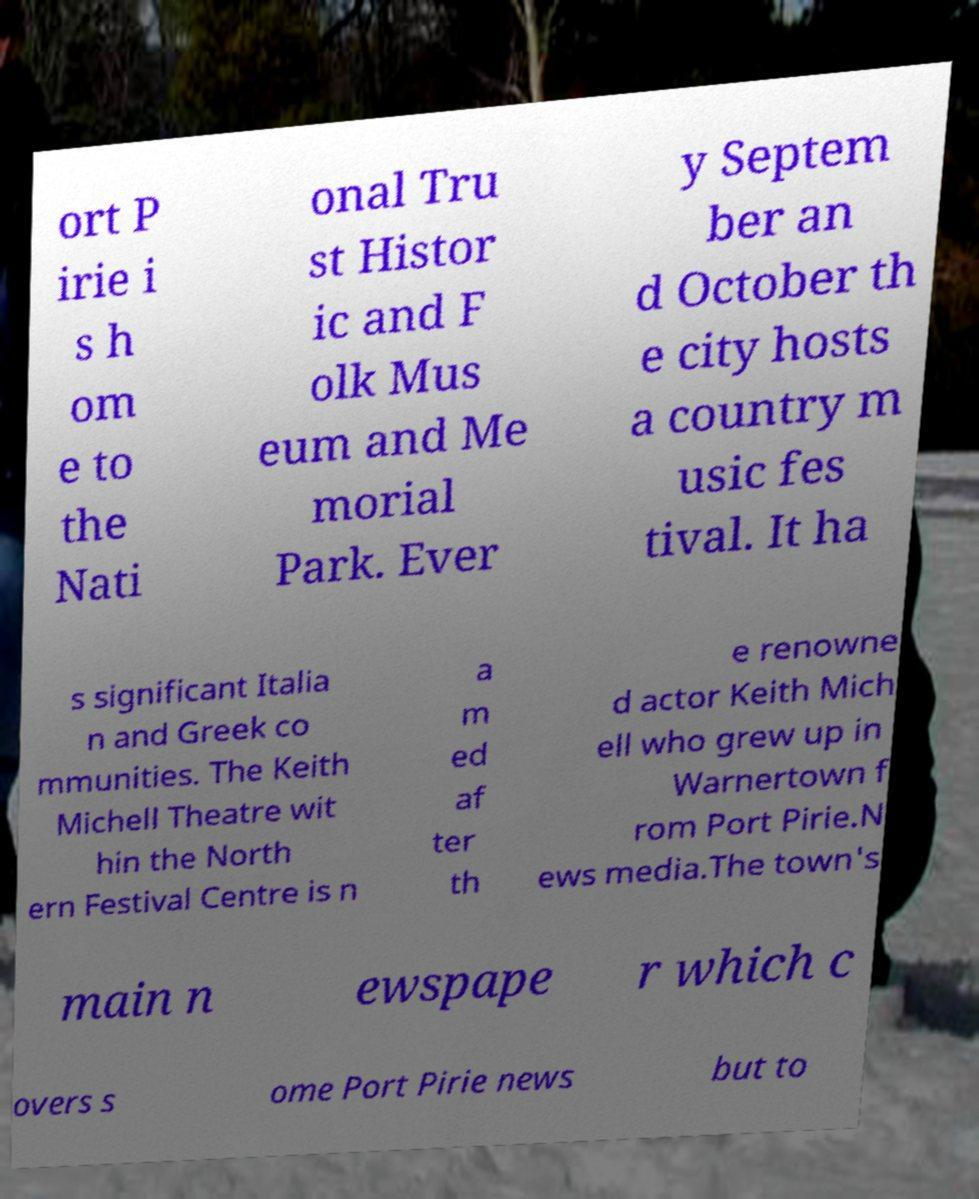Could you assist in decoding the text presented in this image and type it out clearly? ort P irie i s h om e to the Nati onal Tru st Histor ic and F olk Mus eum and Me morial Park. Ever y Septem ber an d October th e city hosts a country m usic fes tival. It ha s significant Italia n and Greek co mmunities. The Keith Michell Theatre wit hin the North ern Festival Centre is n a m ed af ter th e renowne d actor Keith Mich ell who grew up in Warnertown f rom Port Pirie.N ews media.The town's main n ewspape r which c overs s ome Port Pirie news but to 